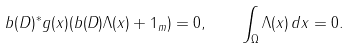<formula> <loc_0><loc_0><loc_500><loc_500>b ( D ) ^ { * } g ( x ) ( b ( D ) \Lambda ( x ) + 1 _ { m } ) = 0 , \quad \int _ { \Omega } \Lambda ( x ) \, d x = 0 .</formula> 